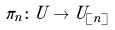<formula> <loc_0><loc_0><loc_500><loc_500>\pi _ { n } \colon U \to U _ { [ n ] }</formula> 